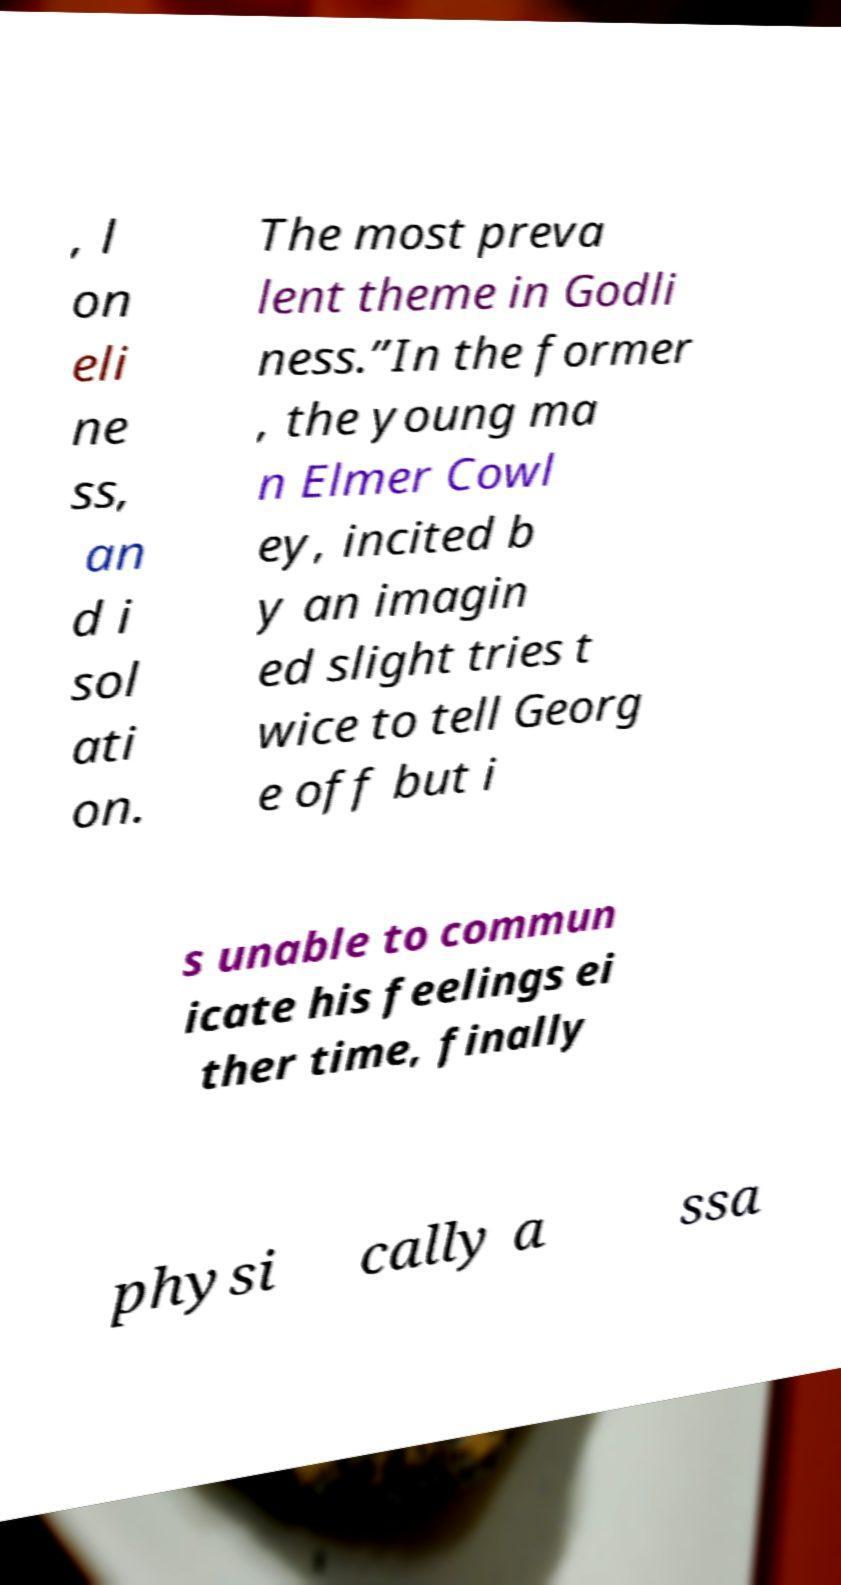Please identify and transcribe the text found in this image. , l on eli ne ss, an d i sol ati on. The most preva lent theme in Godli ness.”In the former , the young ma n Elmer Cowl ey, incited b y an imagin ed slight tries t wice to tell Georg e off but i s unable to commun icate his feelings ei ther time, finally physi cally a ssa 